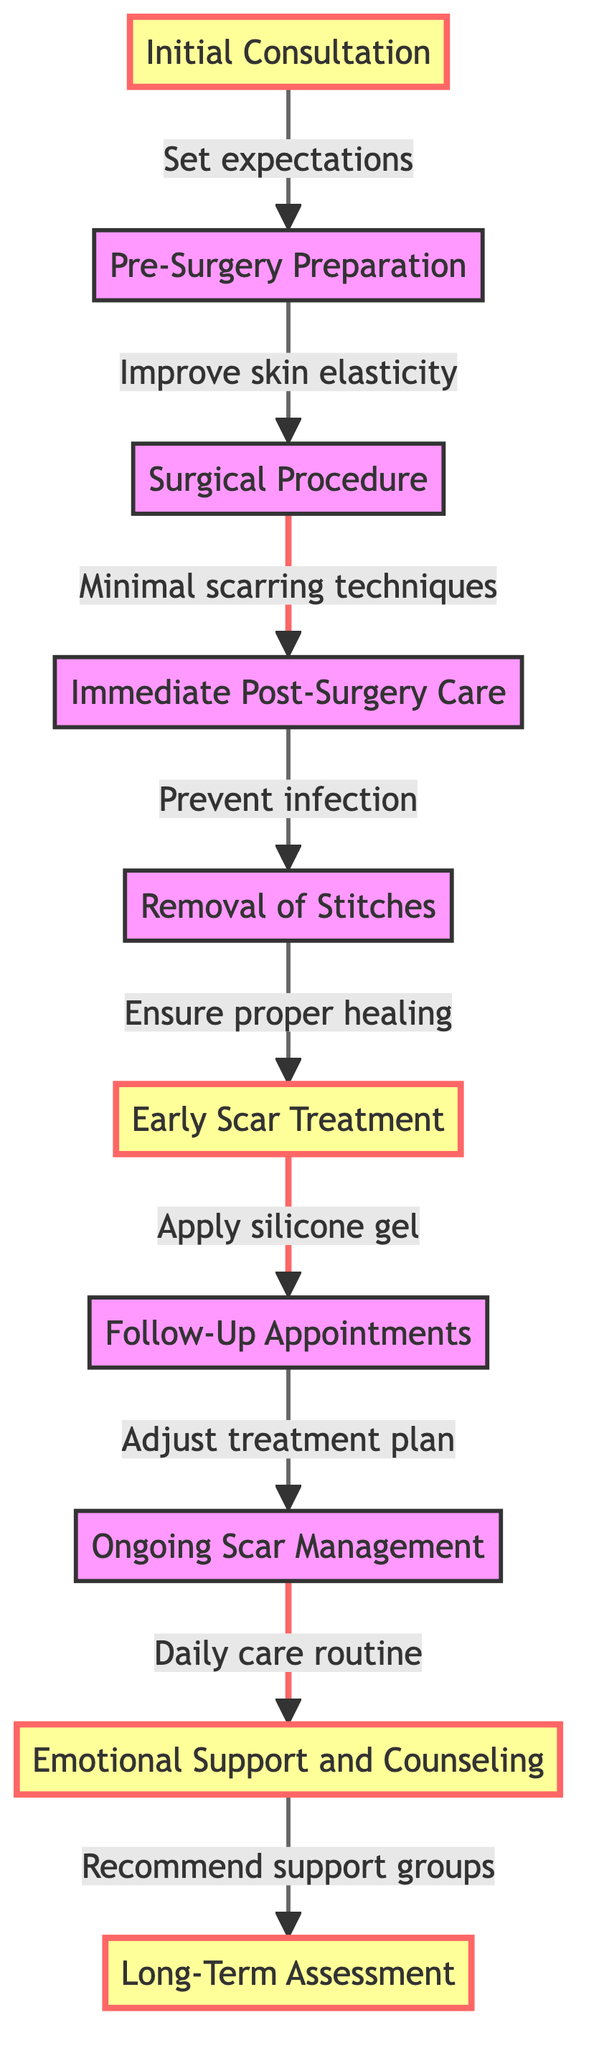What is the first step in the protocol? The diagram starts with the step labeled "Initial Consultation," which is the first node in the flow chart.
Answer: Initial Consultation How many total steps are there in the scar management protocol? The diagram lists a total of ten different steps, each represented as a node in the flow chart.
Answer: Ten What is the key action during the "Early Scar Treatment"? The diagram indicates that the key action during "Early Scar Treatment" involves applying silicone gel or sheets to minimize scar formation.
Answer: Apply silicone gel Which step follows "Removal of Stitches"? The flow chart shows that after "Removal of Stitches," the next step is "Early Scar Treatment," connecting the nodes sequentially.
Answer: Early Scar Treatment What is the last step in the protocol? The last step in the flow chart is labeled "Long-Term Assessment," indicating the final part of the scar management protocol.
Answer: Long-Term Assessment What key action is associated with "Follow-Up Appointments"? The diagram specifies that the key action for "Follow-Up Appointments" is to adjust the treatment plan as necessary with the surgeon's advice.
Answer: Adjust treatment plan Which step requires the application of daily scar care routine and sunblock? The flow chart indicates that the step "Ongoing Scar Management" includes the key action of integrating a daily scar care routine and sunblock for protection.
Answer: Ongoing Scar Management How does “Immediate Post-Surgery Care” connect to “Removal of Stitches”? In the flowchart, "Immediate Post-Surgery Care" leads directly to "Removal of Stitches," indicating that after post-surgery care, the next necessary action is to remove the stitches as scheduled.
Answer: Continuous connection What is the key action mentioned under "Emotional Support and Counseling"? The flowchart notes that the key action for "Emotional Support and Counseling" is to recommend support groups or professional counseling if needed.
Answer: Recommend support groups 